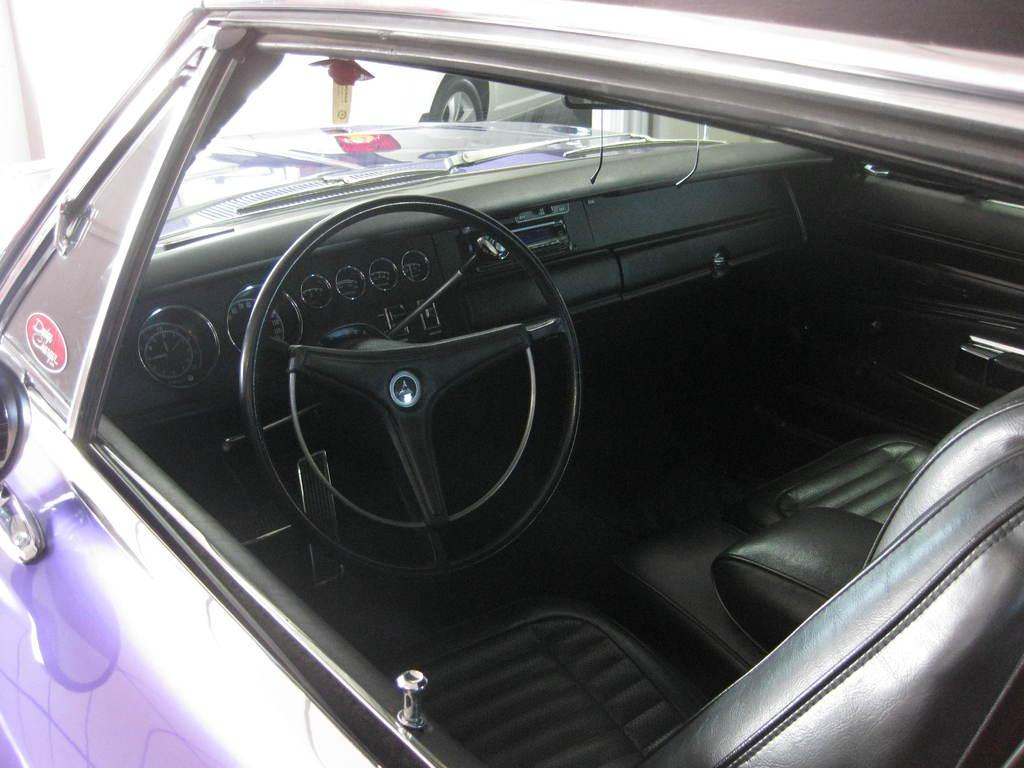What is the main object in the image? There is a steering wheel in the image. What else can be seen in the image related to the main object? There is a dashboard in the image. Are there any other objects in the image related to the main objects? Yes, there are seats in the image. What type of prose is being read by the steering wheel in the image? There is no prose or reading activity present in the image; it features a steering wheel, dashboard, and seats. 